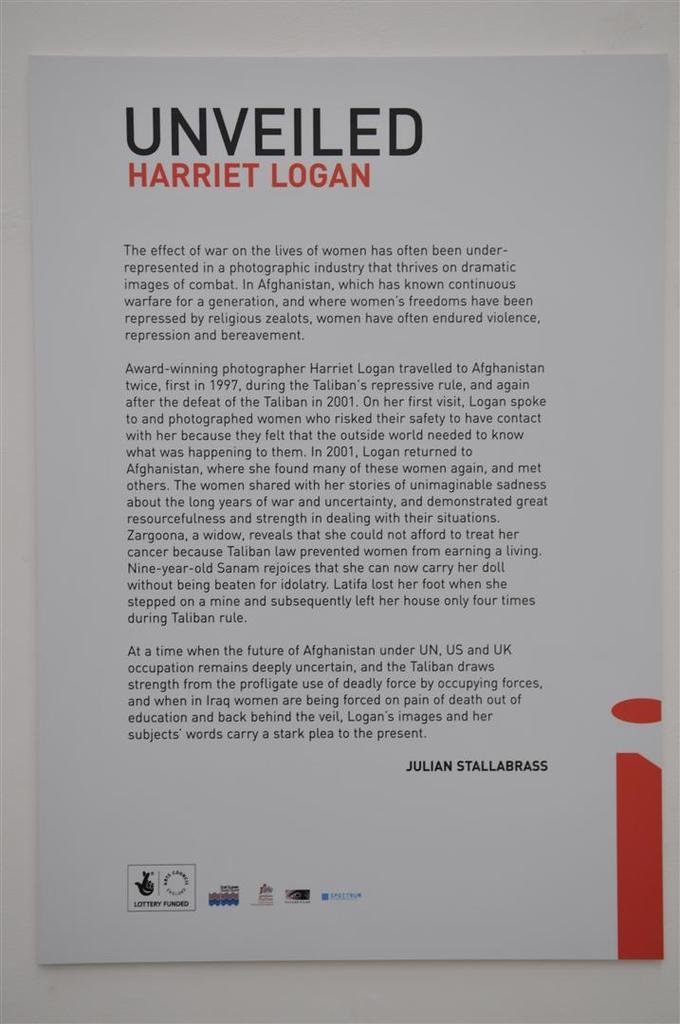<image>
Summarize the visual content of the image. An informational poster has the words Unveiled Harriet Logan at the top. 